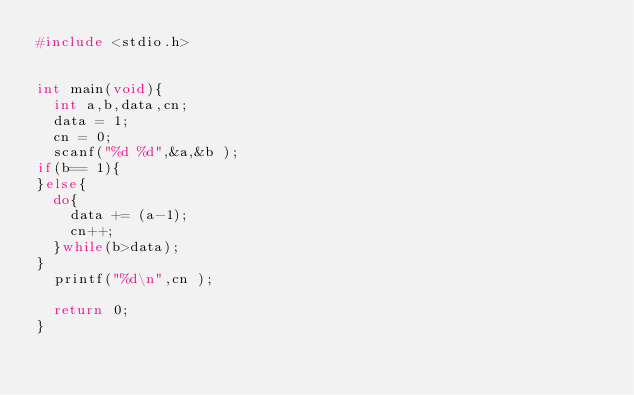Convert code to text. <code><loc_0><loc_0><loc_500><loc_500><_C_>#include <stdio.h>


int main(void){
  int a,b,data,cn;
  data = 1;
  cn = 0;
  scanf("%d %d",&a,&b );
if(b== 1){
}else{
  do{
    data += (a-1);
    cn++;
  }while(b>data);
}
  printf("%d\n",cn );

  return 0;
}
</code> 